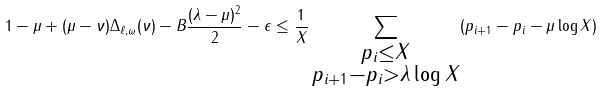Convert formula to latex. <formula><loc_0><loc_0><loc_500><loc_500>1 - \mu + ( \mu - \nu ) \Delta _ { \ell , \omega } ( \nu ) - B \frac { ( \lambda - \mu ) ^ { 2 } } { 2 } - \epsilon \leq \frac { 1 } { X } \sum _ { \substack { p _ { i } \leq X \\ p _ { i + 1 } - p _ { i } > \lambda \log X } } ( p _ { i + 1 } - p _ { i } - \mu \log X )</formula> 